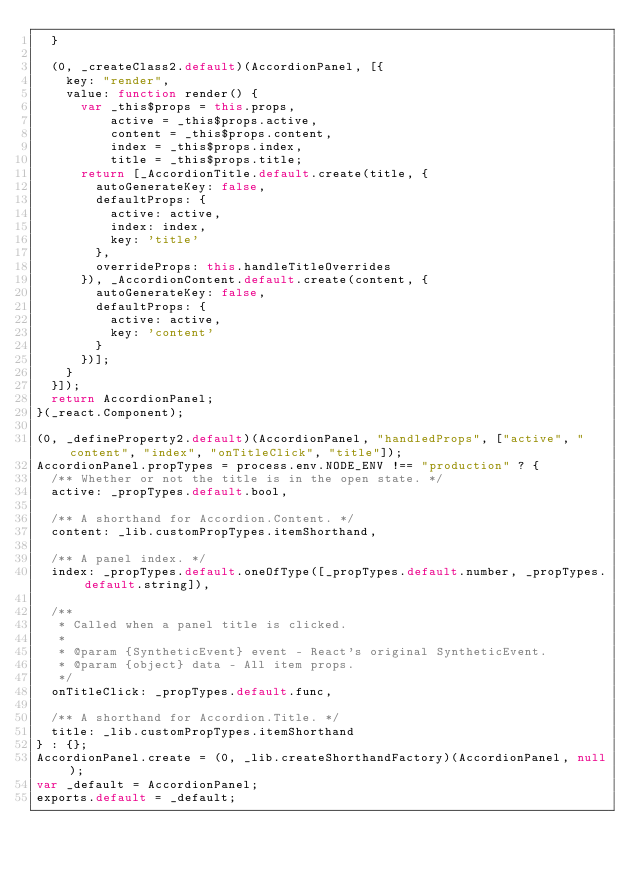Convert code to text. <code><loc_0><loc_0><loc_500><loc_500><_JavaScript_>  }

  (0, _createClass2.default)(AccordionPanel, [{
    key: "render",
    value: function render() {
      var _this$props = this.props,
          active = _this$props.active,
          content = _this$props.content,
          index = _this$props.index,
          title = _this$props.title;
      return [_AccordionTitle.default.create(title, {
        autoGenerateKey: false,
        defaultProps: {
          active: active,
          index: index,
          key: 'title'
        },
        overrideProps: this.handleTitleOverrides
      }), _AccordionContent.default.create(content, {
        autoGenerateKey: false,
        defaultProps: {
          active: active,
          key: 'content'
        }
      })];
    }
  }]);
  return AccordionPanel;
}(_react.Component);

(0, _defineProperty2.default)(AccordionPanel, "handledProps", ["active", "content", "index", "onTitleClick", "title"]);
AccordionPanel.propTypes = process.env.NODE_ENV !== "production" ? {
  /** Whether or not the title is in the open state. */
  active: _propTypes.default.bool,

  /** A shorthand for Accordion.Content. */
  content: _lib.customPropTypes.itemShorthand,

  /** A panel index. */
  index: _propTypes.default.oneOfType([_propTypes.default.number, _propTypes.default.string]),

  /**
   * Called when a panel title is clicked.
   *
   * @param {SyntheticEvent} event - React's original SyntheticEvent.
   * @param {object} data - All item props.
   */
  onTitleClick: _propTypes.default.func,

  /** A shorthand for Accordion.Title. */
  title: _lib.customPropTypes.itemShorthand
} : {};
AccordionPanel.create = (0, _lib.createShorthandFactory)(AccordionPanel, null);
var _default = AccordionPanel;
exports.default = _default;</code> 